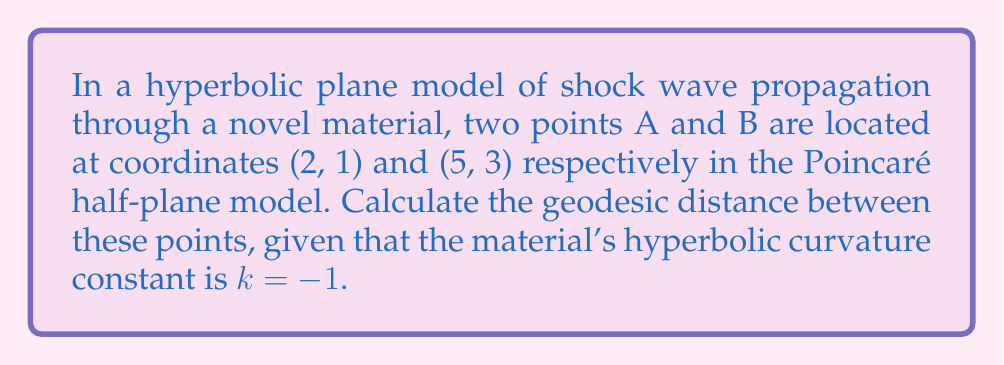Teach me how to tackle this problem. To solve this problem, we'll follow these steps:

1. Recall the formula for geodesic distance in the Poincaré half-plane model:

   $$d(A, B) = \text{arcosh}\left(1 + \frac{(x_2 - x_1)^2 + (y_2 - y_1)^2}{2y_1y_2}\right)$$

   where $(x_1, y_1)$ and $(x_2, y_2)$ are the coordinates of points A and B respectively.

2. Identify the coordinates:
   A: $(x_1, y_1) = (2, 1)$
   B: $(x_2, y_2) = (5, 3)$

3. Substitute these values into the formula:

   $$d(A, B) = \text{arcosh}\left(1 + \frac{(5 - 2)^2 + (3 - 1)^2}{2 \cdot 1 \cdot 3}\right)$$

4. Simplify the expression inside the parentheses:

   $$d(A, B) = \text{arcosh}\left(1 + \frac{3^2 + 2^2}{6}\right) = \text{arcosh}\left(1 + \frac{9 + 4}{6}\right)$$

5. Calculate:

   $$d(A, B) = \text{arcosh}\left(1 + \frac{13}{6}\right) = \text{arcosh}\left(\frac{19}{6}\right)$$

6. The hyperbolic curvature constant $k = -1$ is already incorporated in the Poincaré half-plane model, so no further adjustment is needed.

7. Calculate the final result:

   $$d(A, B) = \text{arcosh}\left(\frac{19}{6}\right) \approx 1.9248$$

This geodesic distance represents the shortest path between points A and B in the hyperbolic plane, modeling the propagation of shock waves through the material.
Answer: $\text{arcosh}\left(\frac{19}{6}\right)$ 